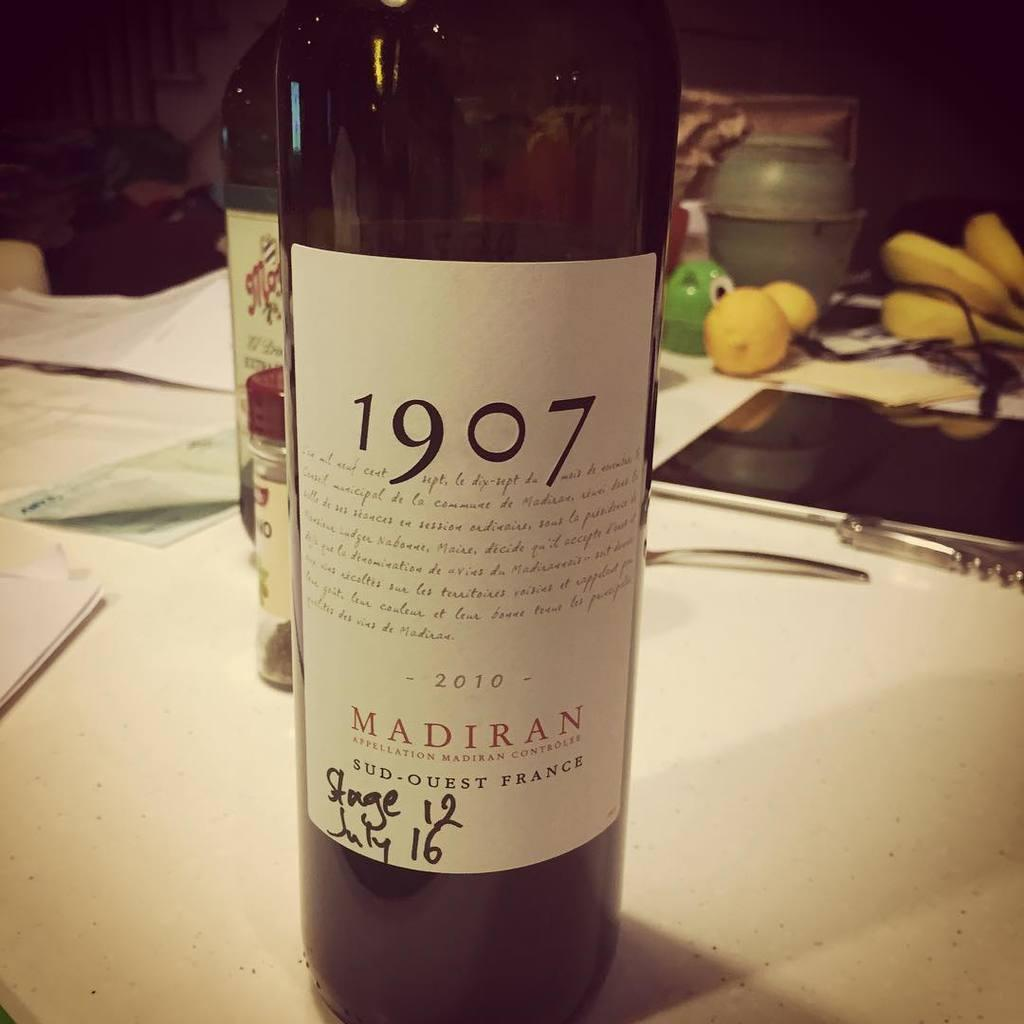<image>
Offer a succinct explanation of the picture presented. A big wine bottle that has the numbers 1907 on it. 